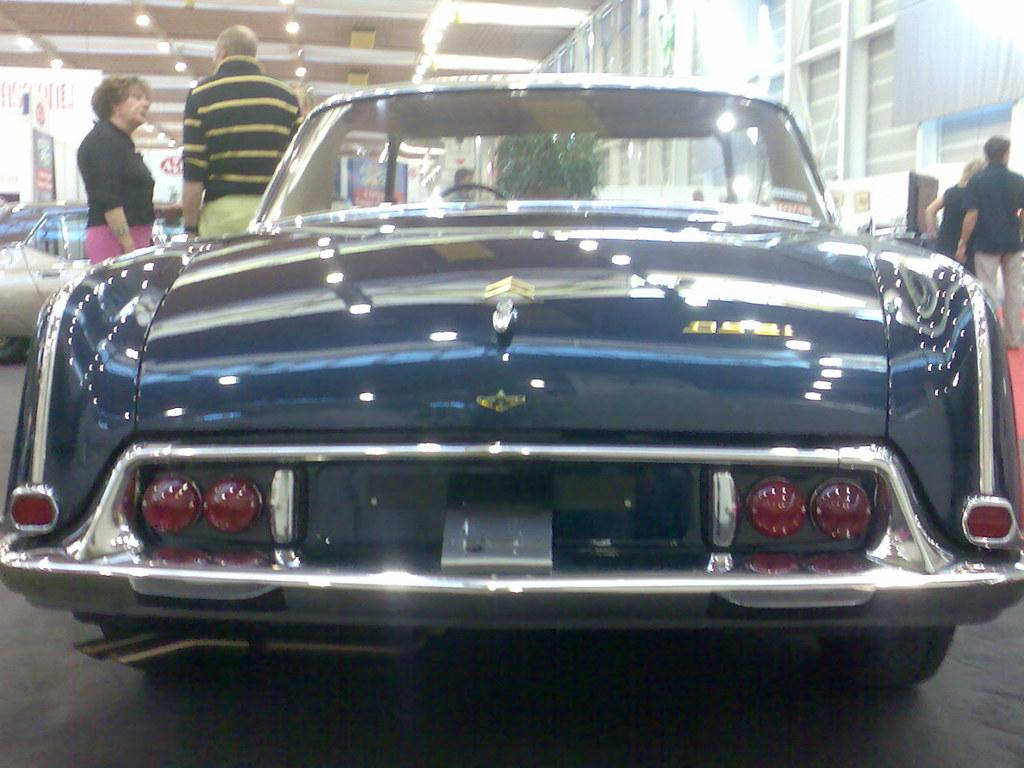What is the main subject of the image? The main subject of the image is a car. Are there any people in the car? Yes, there are people in the back of the car. Can you describe the surrounding environment in the image? There is another car and a plant in the image. What type of lighting is present in the image? There are lights on the ceiling. What color is the grape that is being used as a door handle in the image? There is no grape being used as a door handle in the image. What type of metal is the brass sculpture in the image made of? There is no brass sculpture present in the image. 